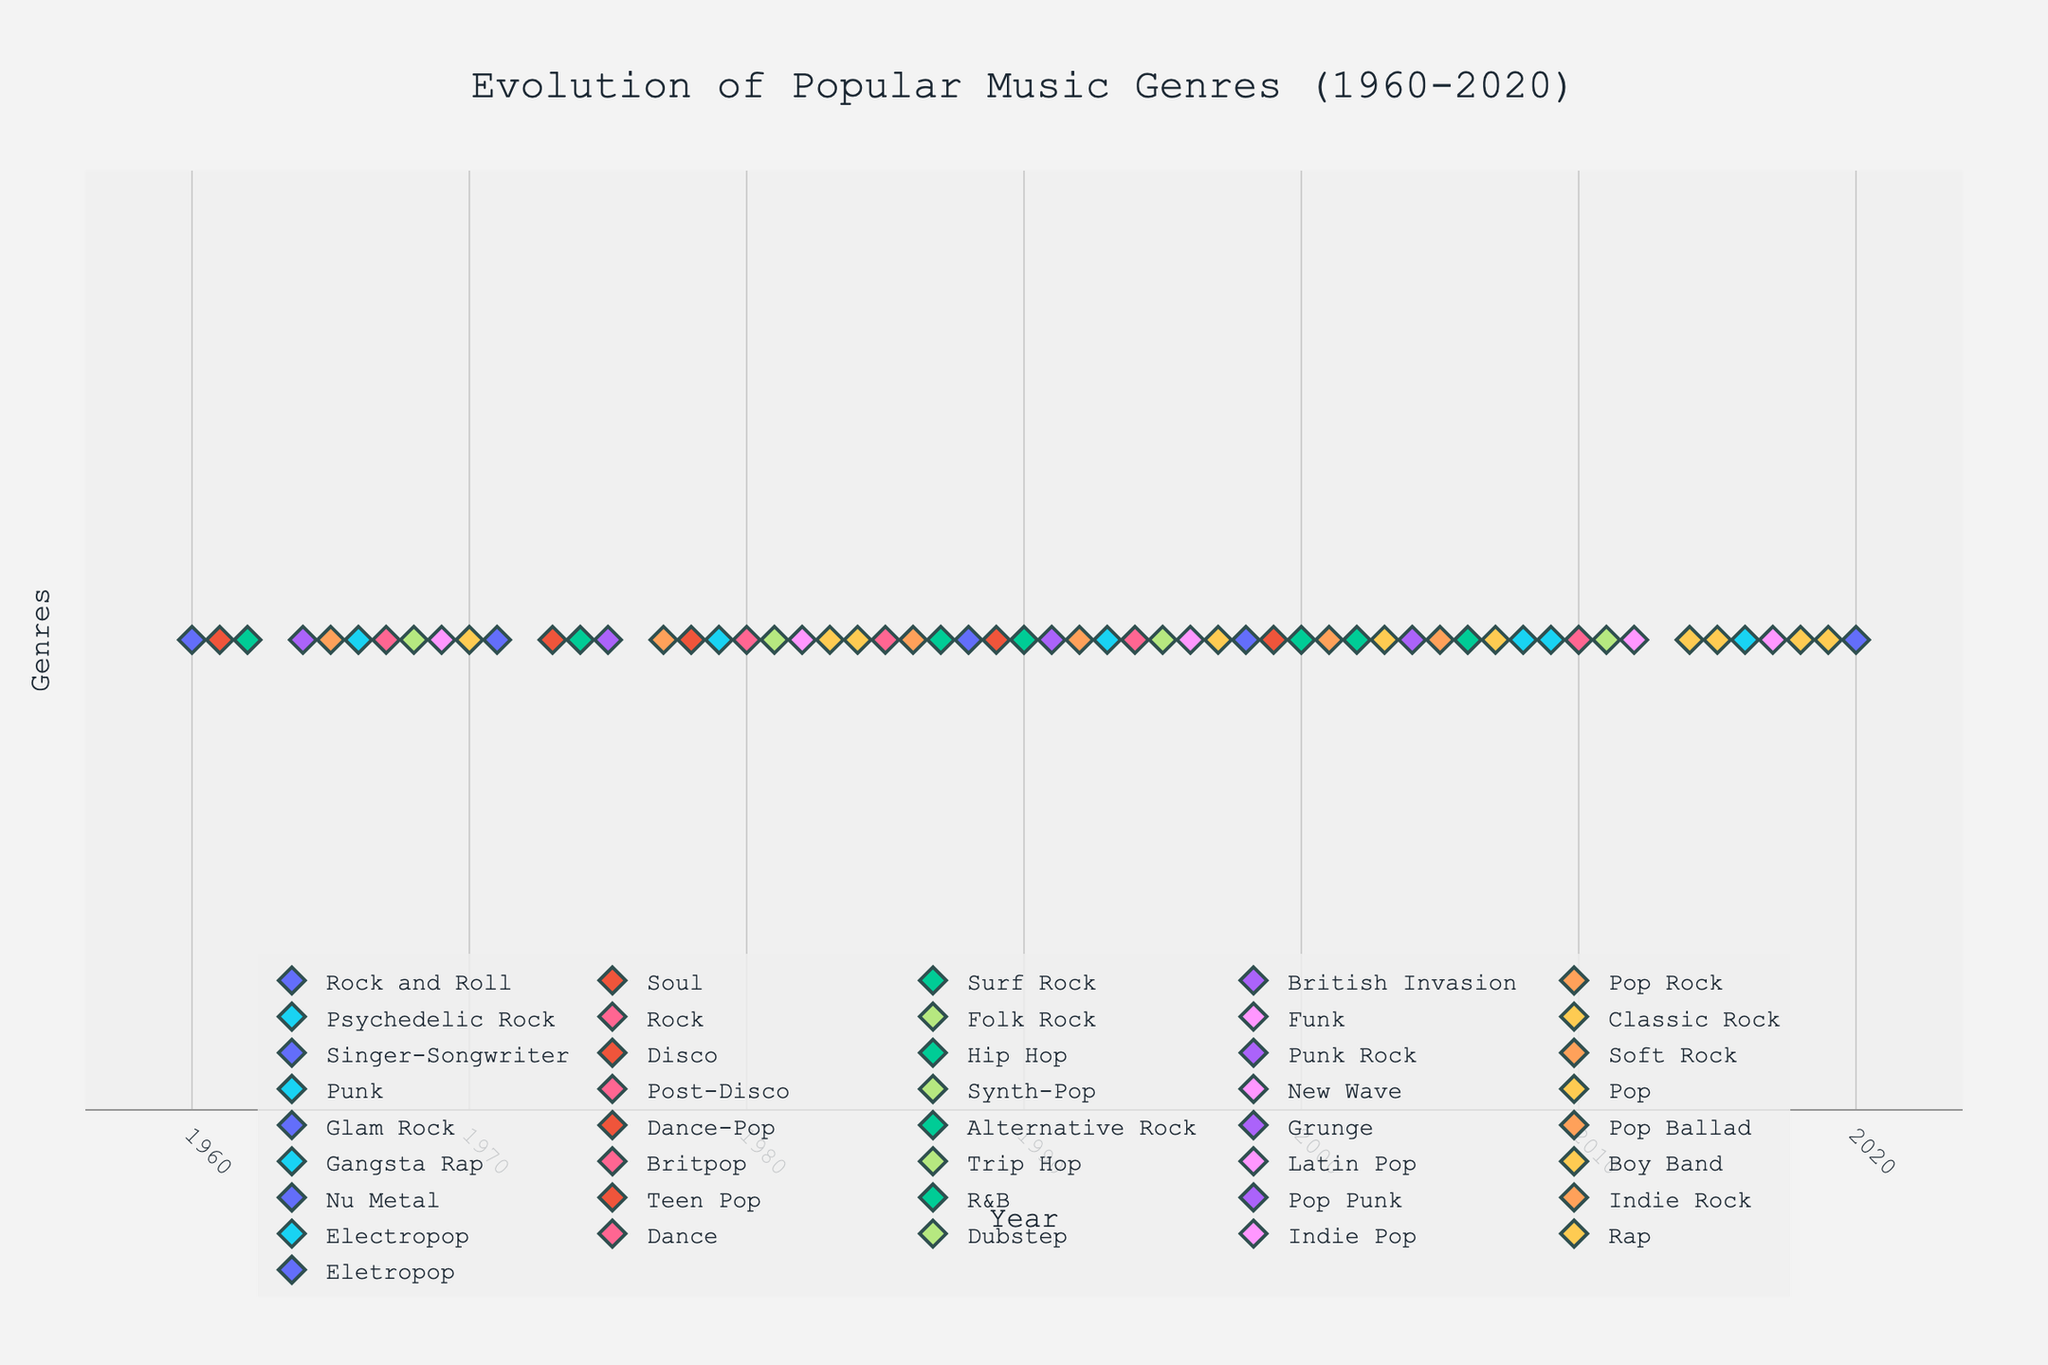What is the title of the figure? The title is usually placed at the top of the figure. In this case, it clearly states the theme of the plot.
Answer: Evolution of Popular Music Genres (1960-2020) Which genre had the most top-chart songs between 1960 and 1970? By observing the clustering of markers for each genre within the specified time range, we can count the occurrences to find the genre with the highest frequency.
Answer: Rock How many different genres appear on the figure? Each unique genre is represented by a different set of markers. Counting the number of unique legend titles gives us the answer.
Answer: 29 Which genres dominated the charts in the 2000s? By looking at the markers from 2000 to 2010, we see which genres' markers frequently appear.
Answer: Pop, Electropop, Indie Rock, Dance, and Hip Hop During which years did Electropop become popular? Identify the years where electropop markers are located by following their positions on the x-axis.
Answer: 2008, 2009, 2016, 2020 What genre had a significant presence in the mid-1980s? By locating the markers around the mid-1980s on the x-axis, we can see which genre repeatedly appears during that time.
Answer: Pop Which year had the highest variety of top-charting genres? Count the number of different genre markers for each year and identify the year with the highest count.
Answer: 1983 Compare the presence of Rock and Hip Hop from 1960 to 2020. Which has more entries overall? Tally up the markers for both Rock and Hip Hop across the entire time span to determine which genre has more appearances.
Answer: Rock From the timeline, which genre appears to start gaining popularity in the late 70s and continue into the 80s? Check for a consistent presence of genre markers starting from the late 70s into the 80s.
Answer: Punk Rock Which genre is represented by the song "Smells Like Teen Spirit" and in which year did it top the charts? Locate the specific song title from the hover text on the markers, and note the associated genre and year.
Answer: Alternative Rock, 1990 